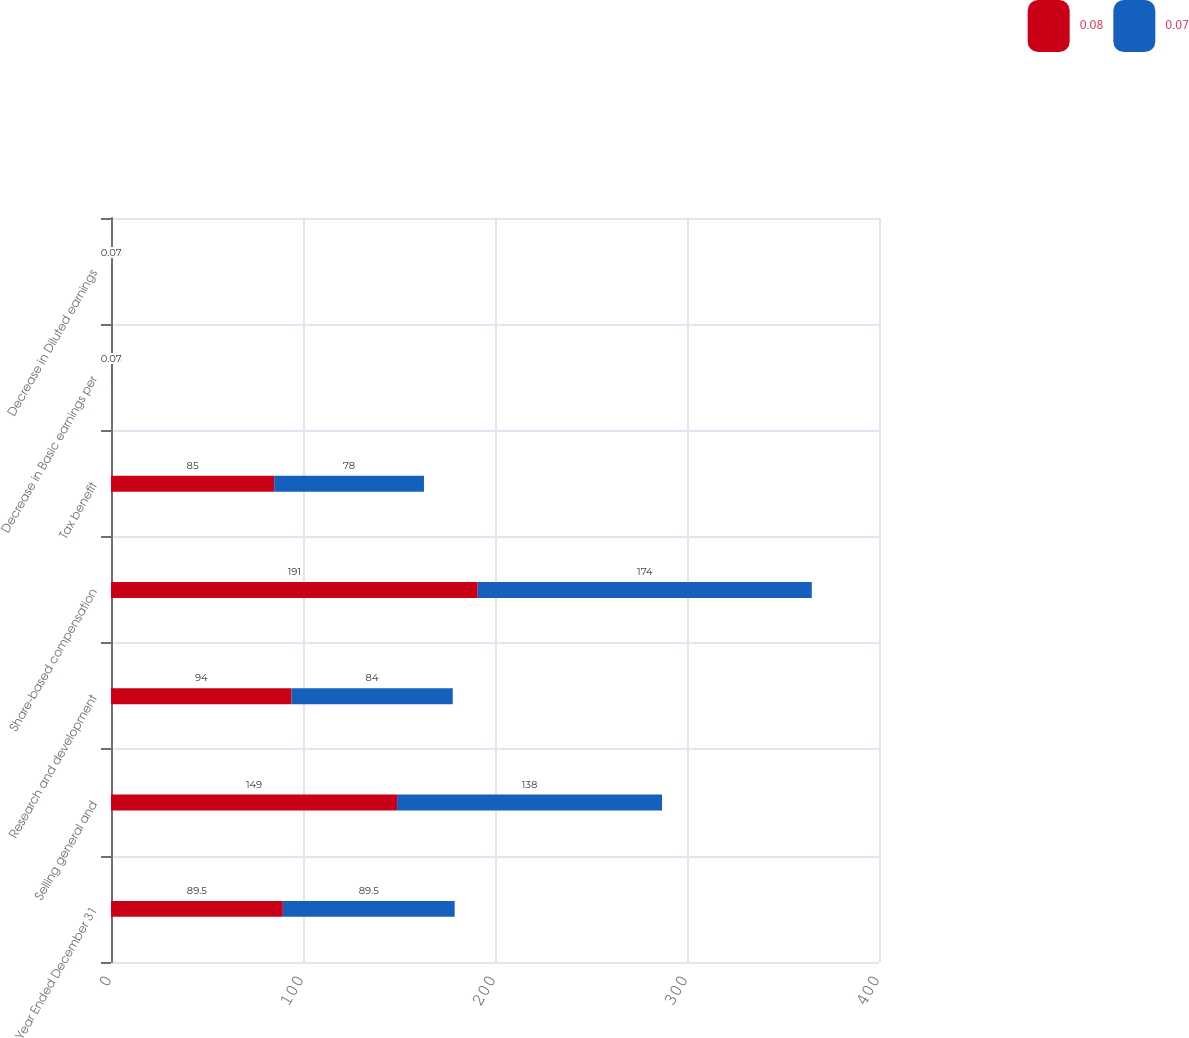Convert chart. <chart><loc_0><loc_0><loc_500><loc_500><stacked_bar_chart><ecel><fcel>Year Ended December 31<fcel>Selling general and<fcel>Research and development<fcel>Share-based compensation<fcel>Tax benefit<fcel>Decrease in Basic earnings per<fcel>Decrease in Diluted earnings<nl><fcel>0.08<fcel>89.5<fcel>149<fcel>94<fcel>191<fcel>85<fcel>0.08<fcel>0.08<nl><fcel>0.07<fcel>89.5<fcel>138<fcel>84<fcel>174<fcel>78<fcel>0.07<fcel>0.07<nl></chart> 